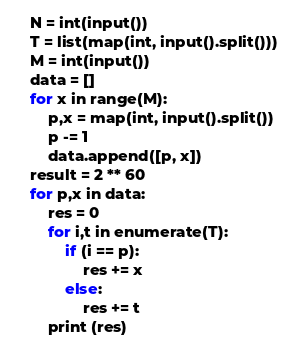<code> <loc_0><loc_0><loc_500><loc_500><_Python_>
    N = int(input())
    T = list(map(int, input().split()))
    M = int(input())
    data = []
    for x in range(M):
        p,x = map(int, input().split())
        p -= 1
        data.append([p, x])
    result = 2 ** 60
    for p,x in data:
        res = 0
        for i,t in enumerate(T):
            if (i == p):
                res += x
            else:
                res += t
        print (res)</code> 